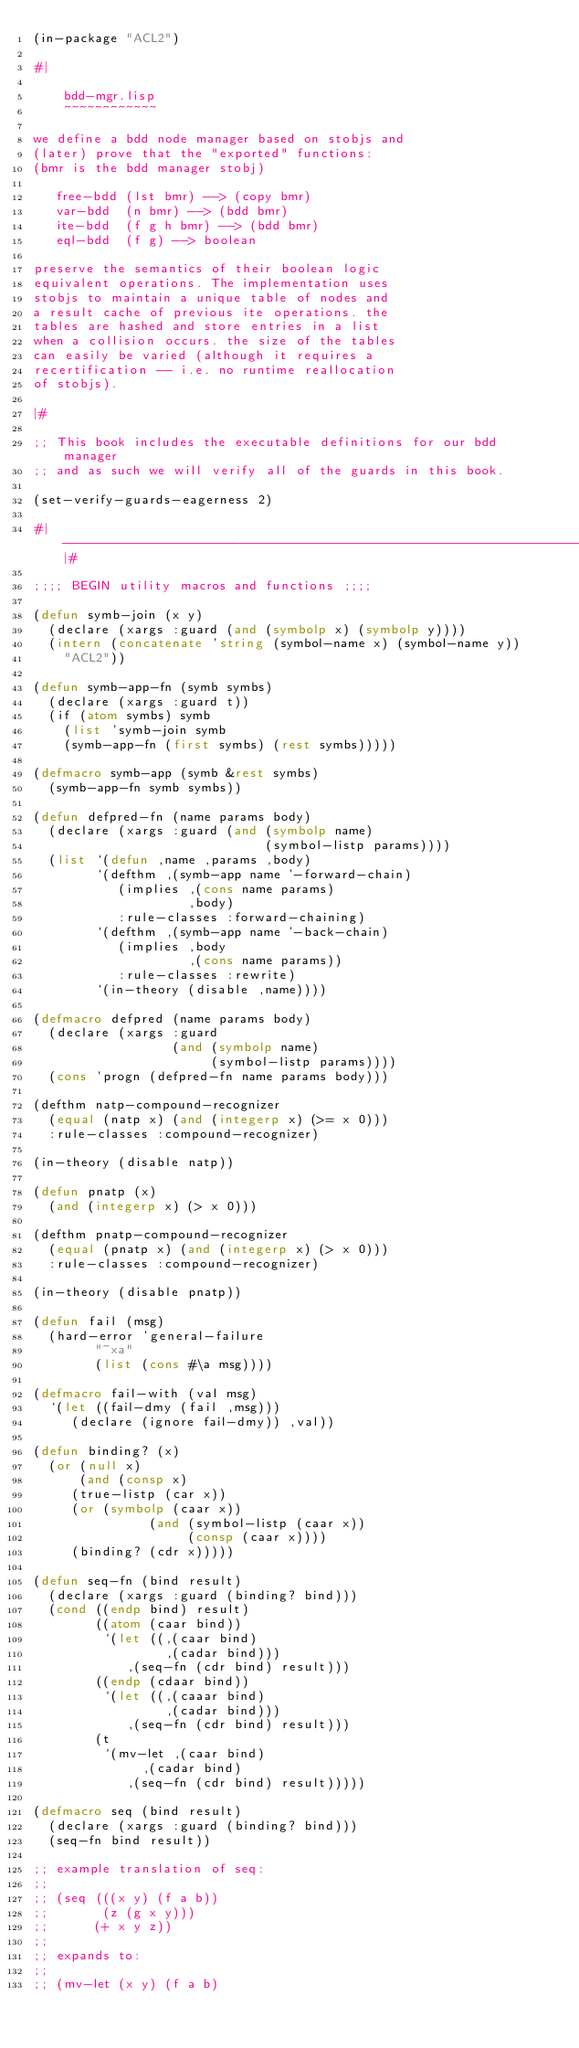<code> <loc_0><loc_0><loc_500><loc_500><_Lisp_>(in-package "ACL2")

#|

    bdd-mgr.lisp
    ~~~~~~~~~~~~

we define a bdd node manager based on stobjs and
(later) prove that the "exported" functions:
(bmr is the bdd manager stobj)

   free-bdd (lst bmr) --> (copy bmr)
   var-bdd  (n bmr) --> (bdd bmr)
   ite-bdd  (f g h bmr) --> (bdd bmr)
   eql-bdd  (f g) --> boolean

preserve the semantics of their boolean logic
equivalent operations. The implementation uses
stobjs to maintain a unique table of nodes and
a result cache of previous ite operations. the
tables are hashed and store entries in a list
when a collision occurs. the size of the tables
can easily be varied (although it requires a
recertification -- i.e. no runtime reallocation
of stobjs).

|#

;; This book includes the executable definitions for our bdd manager
;; and as such we will verify all of the guards in this book.

(set-verify-guards-eagerness 2)

#|----------------------------------------------------------------------------|#

;;;; BEGIN utility macros and functions ;;;;

(defun symb-join (x y)
  (declare (xargs :guard (and (symbolp x) (symbolp y))))
  (intern (concatenate 'string (symbol-name x) (symbol-name y))
	  "ACL2"))

(defun symb-app-fn (symb symbs)
  (declare (xargs :guard t))
  (if (atom symbs) symb
    (list 'symb-join symb
	  (symb-app-fn (first symbs) (rest symbs)))))

(defmacro symb-app (symb &rest symbs)
  (symb-app-fn symb symbs))

(defun defpred-fn (name params body)
  (declare (xargs :guard (and (symbolp name)
                              (symbol-listp params))))
  (list `(defun ,name ,params ,body)
        `(defthm ,(symb-app name '-forward-chain)
           (implies ,(cons name params)
                    ,body)
           :rule-classes :forward-chaining)
        `(defthm ,(symb-app name '-back-chain)
           (implies ,body
                    ,(cons name params))
           :rule-classes :rewrite)
        `(in-theory (disable ,name))))

(defmacro defpred (name params body)
  (declare (xargs :guard
                  (and (symbolp name)
                       (symbol-listp params))))
  (cons 'progn (defpred-fn name params body)))

(defthm natp-compound-recognizer
  (equal (natp x) (and (integerp x) (>= x 0)))
  :rule-classes :compound-recognizer)

(in-theory (disable natp))

(defun pnatp (x)
  (and (integerp x) (> x 0)))

(defthm pnatp-compound-recognizer
  (equal (pnatp x) (and (integerp x) (> x 0)))
  :rule-classes :compound-recognizer)

(in-theory (disable pnatp))

(defun fail (msg)
  (hard-error 'general-failure
	      "~xa"
	      (list (cons #\a msg))))

(defmacro fail-with (val msg)
  `(let ((fail-dmy (fail ,msg)))
     (declare (ignore fail-dmy)) ,val))

(defun binding? (x)
  (or (null x)
      (and (consp x)
	   (true-listp (car x))
	   (or (symbolp (caar x))
               (and (symbol-listp (caar x))
                    (consp (caar x))))
	   (binding? (cdr x)))))

(defun seq-fn (bind result)
  (declare (xargs :guard (binding? bind)))
  (cond ((endp bind) result)
        ((atom (caar bind))
         `(let ((,(caar bind)
                 ,(cadar bind)))
            ,(seq-fn (cdr bind) result)))
        ((endp (cdaar bind))
         `(let ((,(caaar bind)
                 ,(cadar bind)))
            ,(seq-fn (cdr bind) result)))
        (t
         `(mv-let ,(caar bind)
              ,(cadar bind)
            ,(seq-fn (cdr bind) result)))))

(defmacro seq (bind result)
  (declare (xargs :guard (binding? bind)))
  (seq-fn bind result))

;; example translation of seq:
;;
;; (seq (((x y) (f a b))
;;       (z (g x y)))
;;      (+ x y z))
;;
;; expands to:
;;
;; (mv-let (x y) (f a b)</code> 